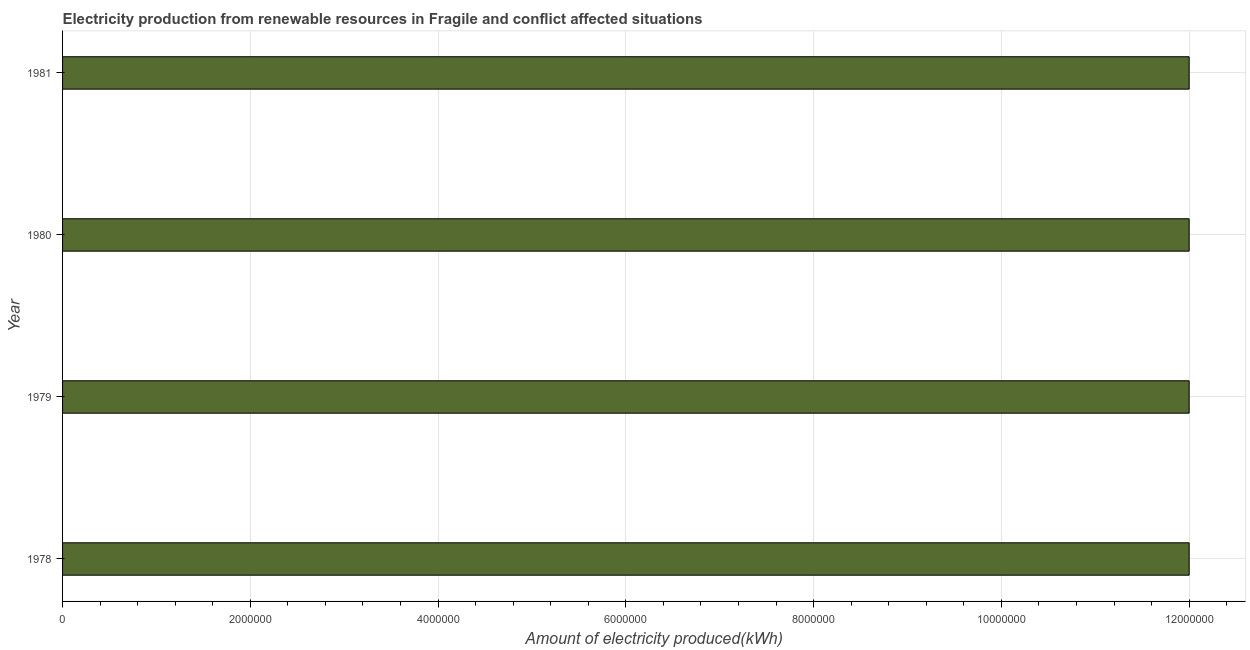Does the graph contain any zero values?
Give a very brief answer. No. Does the graph contain grids?
Keep it short and to the point. Yes. What is the title of the graph?
Your answer should be very brief. Electricity production from renewable resources in Fragile and conflict affected situations. What is the label or title of the X-axis?
Ensure brevity in your answer.  Amount of electricity produced(kWh). What is the label or title of the Y-axis?
Your answer should be very brief. Year. Across all years, what is the maximum amount of electricity produced?
Offer a terse response. 1.20e+07. Across all years, what is the minimum amount of electricity produced?
Provide a succinct answer. 1.20e+07. In which year was the amount of electricity produced maximum?
Keep it short and to the point. 1978. In which year was the amount of electricity produced minimum?
Provide a succinct answer. 1978. What is the sum of the amount of electricity produced?
Your response must be concise. 4.80e+07. What is the difference between the amount of electricity produced in 1980 and 1981?
Provide a short and direct response. 0. What is the ratio of the amount of electricity produced in 1979 to that in 1980?
Offer a very short reply. 1. Is the amount of electricity produced in 1978 less than that in 1980?
Keep it short and to the point. No. What is the difference between the highest and the second highest amount of electricity produced?
Your answer should be very brief. 0. What is the difference between the highest and the lowest amount of electricity produced?
Your response must be concise. 0. In how many years, is the amount of electricity produced greater than the average amount of electricity produced taken over all years?
Provide a short and direct response. 0. How many bars are there?
Offer a terse response. 4. What is the difference between two consecutive major ticks on the X-axis?
Ensure brevity in your answer.  2.00e+06. Are the values on the major ticks of X-axis written in scientific E-notation?
Give a very brief answer. No. What is the Amount of electricity produced(kWh) of 1978?
Give a very brief answer. 1.20e+07. What is the Amount of electricity produced(kWh) in 1980?
Provide a succinct answer. 1.20e+07. What is the Amount of electricity produced(kWh) in 1981?
Your answer should be very brief. 1.20e+07. What is the difference between the Amount of electricity produced(kWh) in 1979 and 1980?
Your answer should be compact. 0. What is the difference between the Amount of electricity produced(kWh) in 1979 and 1981?
Offer a terse response. 0. What is the difference between the Amount of electricity produced(kWh) in 1980 and 1981?
Your response must be concise. 0. What is the ratio of the Amount of electricity produced(kWh) in 1978 to that in 1980?
Make the answer very short. 1. What is the ratio of the Amount of electricity produced(kWh) in 1978 to that in 1981?
Provide a short and direct response. 1. 